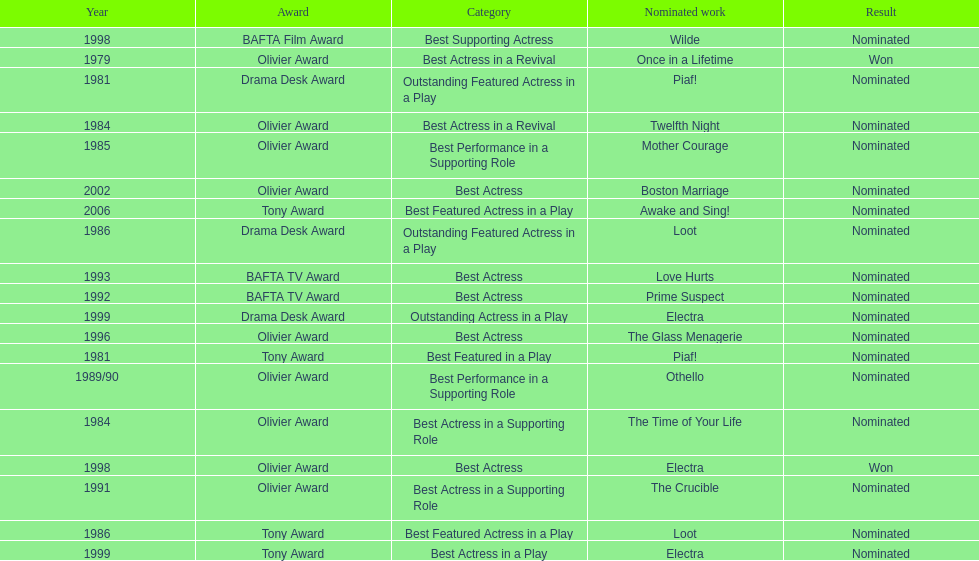What play was wanamaker nominated for best actress in a revival in 1984? Twelfth Night. 